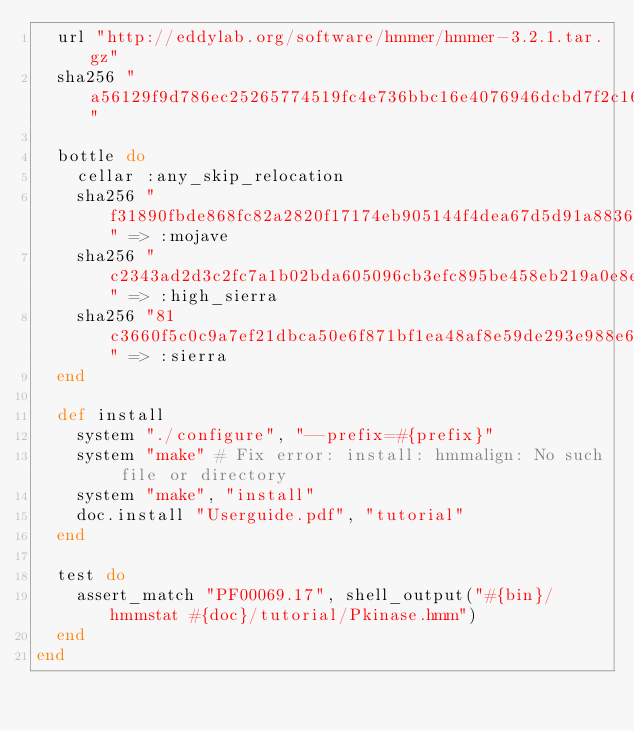Convert code to text. <code><loc_0><loc_0><loc_500><loc_500><_Ruby_>  url "http://eddylab.org/software/hmmer/hmmer-3.2.1.tar.gz"
  sha256 "a56129f9d786ec25265774519fc4e736bbc16e4076946dcbd7f2c16efc8e2b9c"

  bottle do
    cellar :any_skip_relocation
    sha256 "f31890fbde868fc82a2820f17174eb905144f4dea67d5d91a88363645279341b" => :mojave
    sha256 "c2343ad2d3c2fc7a1b02bda605096cb3efc895be458eb219a0e8eee3cc805474" => :high_sierra
    sha256 "81c3660f5c0c9a7ef21dbca50e6f871bf1ea48af8e59de293e988e682dc16e6e" => :sierra
  end

  def install
    system "./configure", "--prefix=#{prefix}"
    system "make" # Fix error: install: hmmalign: No such file or directory
    system "make", "install"
    doc.install "Userguide.pdf", "tutorial"
  end

  test do
    assert_match "PF00069.17", shell_output("#{bin}/hmmstat #{doc}/tutorial/Pkinase.hmm")
  end
end
</code> 